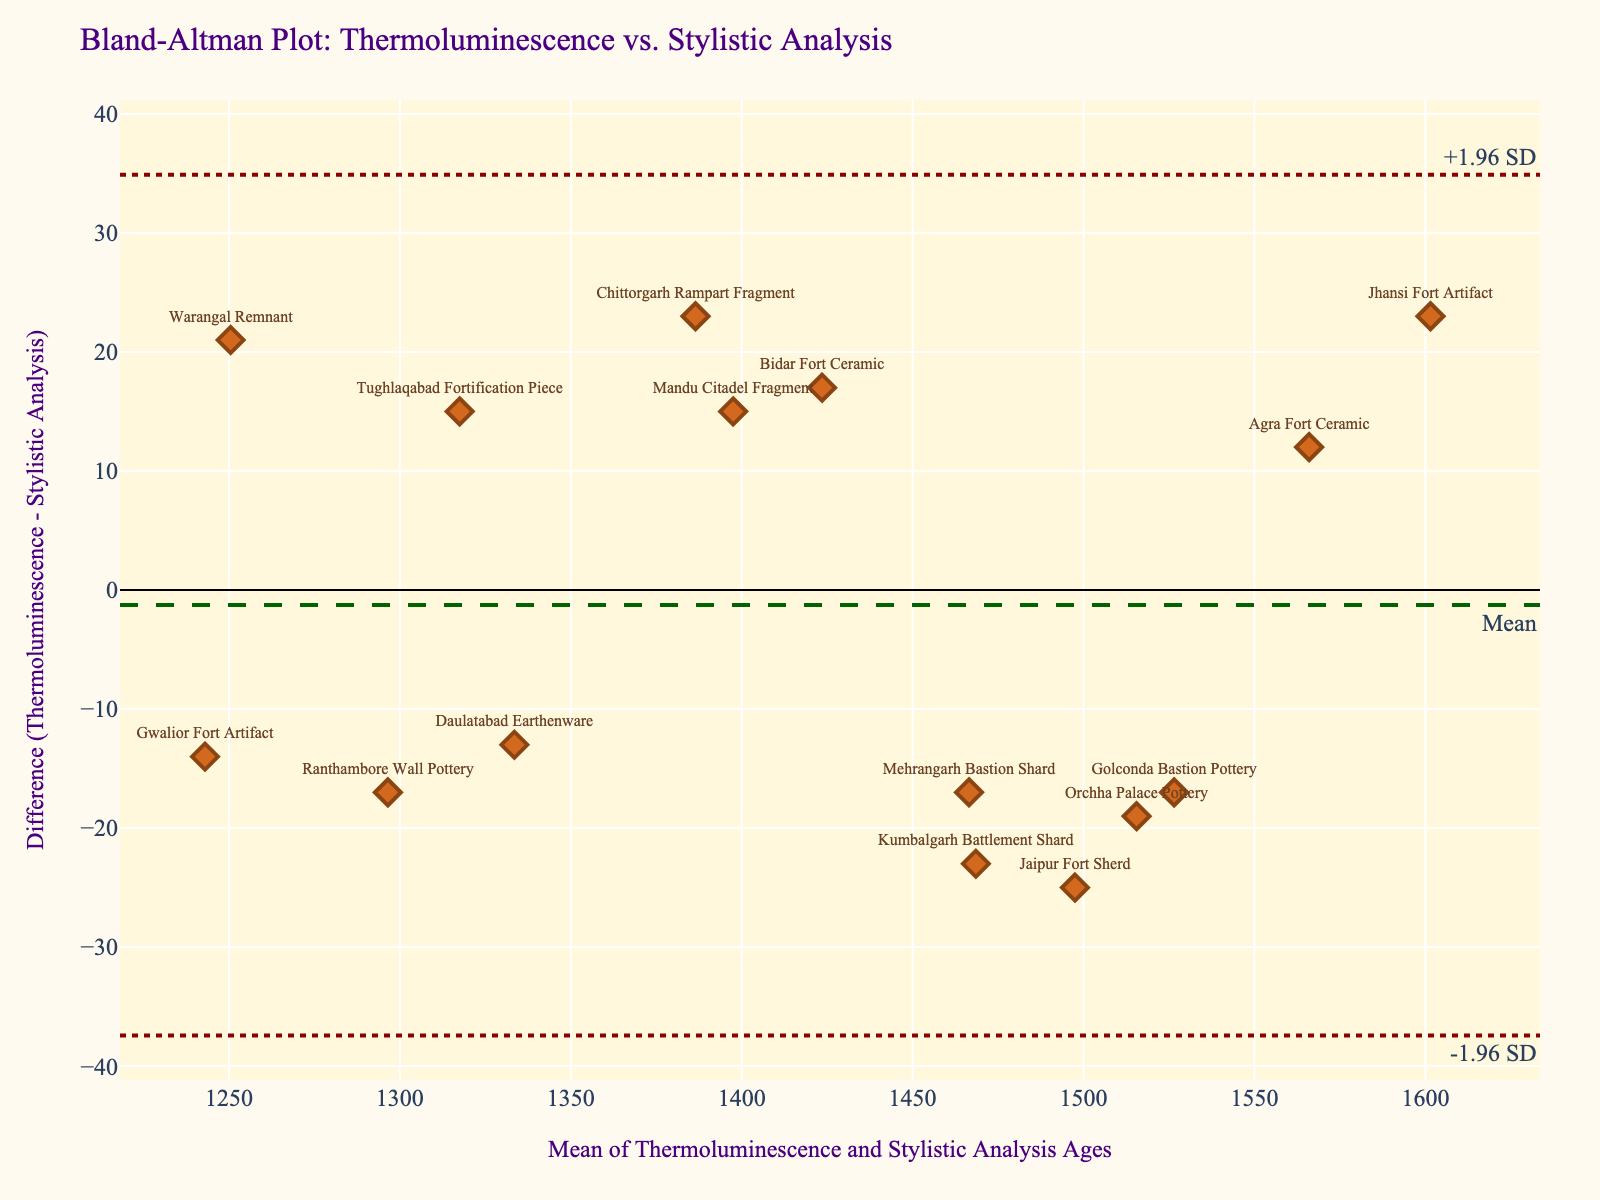What is the title of the plot? The title of the plot can be found at the top, providing a brief description of the content being illustrated. By reading the text at the top of the plot, we can see it says "Bland-Altman Plot: Thermoluminescence vs. Stylistic Analysis."
Answer: Bland-Altman Plot: Thermoluminescence vs. Stylistic Analysis What is shown on the x-axis of the plot? The x-axis typically denotes the independent variable or the combined measure of two variables in Bland-Altman plots. Here, the label on the x-axis reads "Mean of Thermoluminescence and Stylistic Analysis Ages."
Answer: Mean of Thermoluminescence and Stylistic Analysis Ages How is the mean difference represented in the plot? The mean difference is usually represented by a horizontal line across the plot. The plot shows a dashed line with the annotation "Mean," indicating the mean difference between the thermoluminescence and stylistic analysis ages.
Answer: Dashed horizontal line labeled "Mean" What is the difference between thermoluminescence and stylistic analysis ages for the "Mandu Citadel Fragment"? To find this, locate the "Mandu Citadel Fragment" point on the plot, then see the corresponding difference value on the y-axis. The thermoluminescence age for Mandu Citadel Fragment is 1405 years, and the stylistic analysis age is 1390 years, so the difference is 1405 - 1390.
Answer: 15 Which pottery fragment has the largest difference in ages? To determine this, identify the point with the highest absolute value on the y-axis. By examining the plot, the "Jaipur Fort Sherd" with a large positive difference, stands out the most.
Answer: Jaipur Fort Sherd What are the approximate upper and lower limits of agreement in the plot? The upper and lower limits of agreement in a Bland-Altman plot are shown as dotted lines. By observing the plot, the +1.96 SD line and the -1.96 SD line represent these limits.
Answer: +1.96 SD and -1.96 SD Describe the visual appearance of the data points in the plot. Data points in the plot are shown as diamond markers, with annotations indicating the pottery fragment. They are colored in a shade of brown and include a border of a darker brown color.
Answer: Diamond markers with brown color and darker brown borders Are there any data points that lie outside the limits of agreement? To answer this, observe if any points lie beyond the dotted horizontal lines representing +1.96 SD and -1.96 SD. By scanning the plot, no data points appear to fall outside these lines, so all data points are within limits.
Answer: No What is the central tendency of the differences between the two methods? The central tendency in a Bland-Altman plot is often indicated by the mean difference. This is shown by the dashed horizontal line with the "Mean" label on the plot. The value at this line represents the central trend.
Answer: The mean difference line 